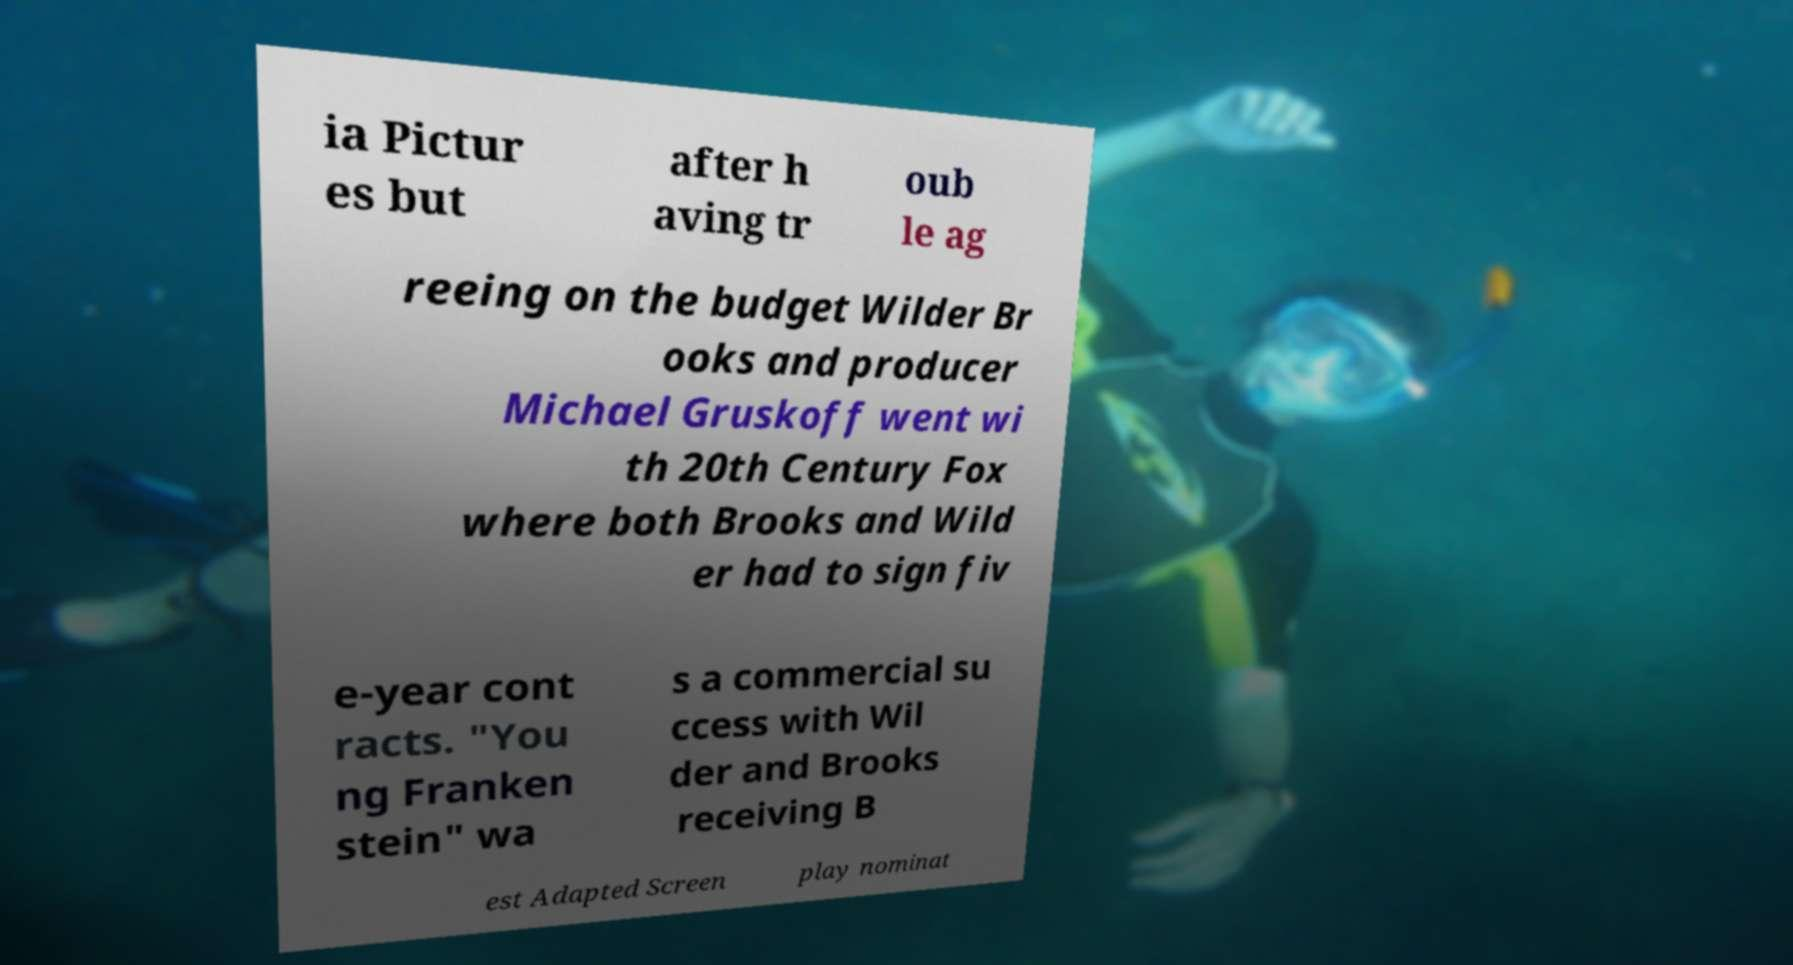I need the written content from this picture converted into text. Can you do that? ia Pictur es but after h aving tr oub le ag reeing on the budget Wilder Br ooks and producer Michael Gruskoff went wi th 20th Century Fox where both Brooks and Wild er had to sign fiv e-year cont racts. "You ng Franken stein" wa s a commercial su ccess with Wil der and Brooks receiving B est Adapted Screen play nominat 